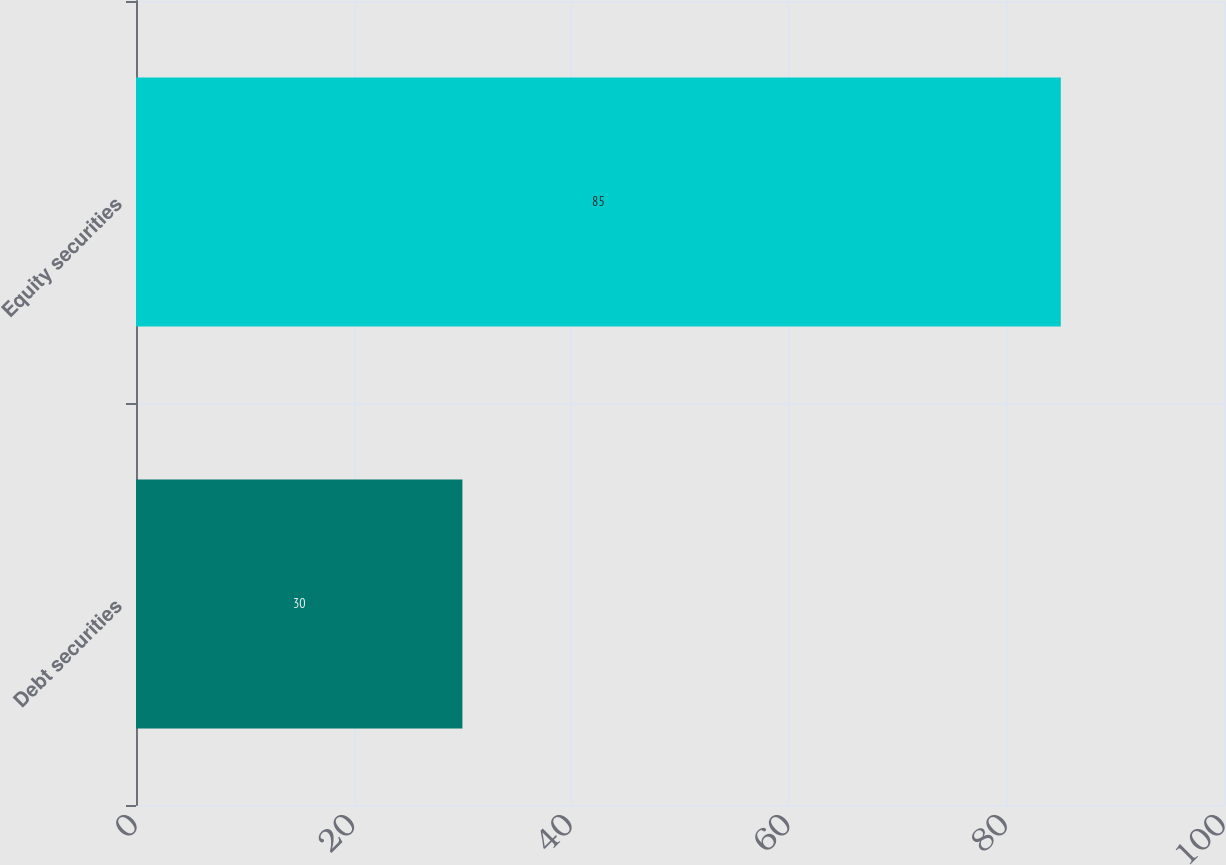<chart> <loc_0><loc_0><loc_500><loc_500><bar_chart><fcel>Debt securities<fcel>Equity securities<nl><fcel>30<fcel>85<nl></chart> 